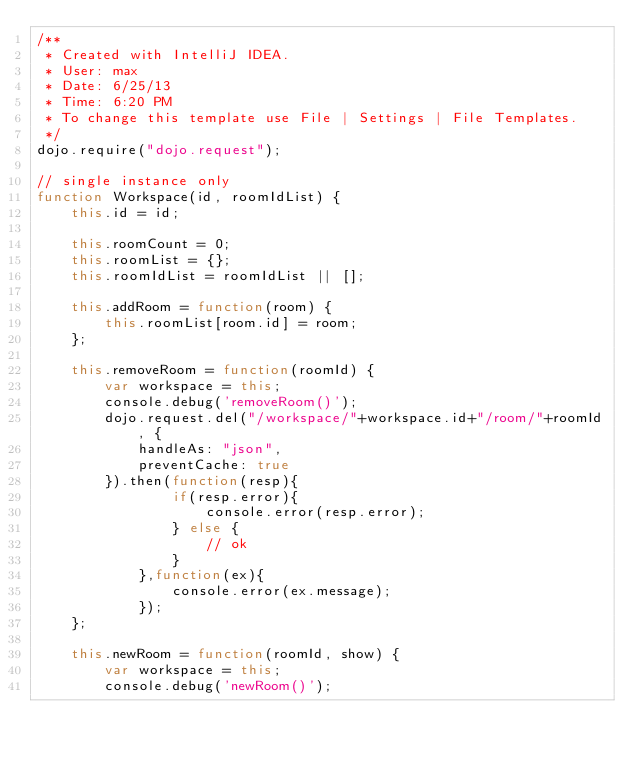Convert code to text. <code><loc_0><loc_0><loc_500><loc_500><_JavaScript_>/**
 * Created with IntelliJ IDEA.
 * User: max
 * Date: 6/25/13
 * Time: 6:20 PM
 * To change this template use File | Settings | File Templates.
 */
dojo.require("dojo.request");

// single instance only
function Workspace(id, roomIdList) {
    this.id = id;

    this.roomCount = 0;
    this.roomList = {};
    this.roomIdList = roomIdList || [];

    this.addRoom = function(room) {
        this.roomList[room.id] = room;
    };

    this.removeRoom = function(roomId) {
        var workspace = this;
        console.debug('removeRoom()');
        dojo.request.del("/workspace/"+workspace.id+"/room/"+roomId, {
            handleAs: "json",
            preventCache: true
        }).then(function(resp){
                if(resp.error){
                    console.error(resp.error);
                } else {
                    // ok
                }
            },function(ex){
                console.error(ex.message);
            });
    };

    this.newRoom = function(roomId, show) {
        var workspace = this;
        console.debug('newRoom()');</code> 